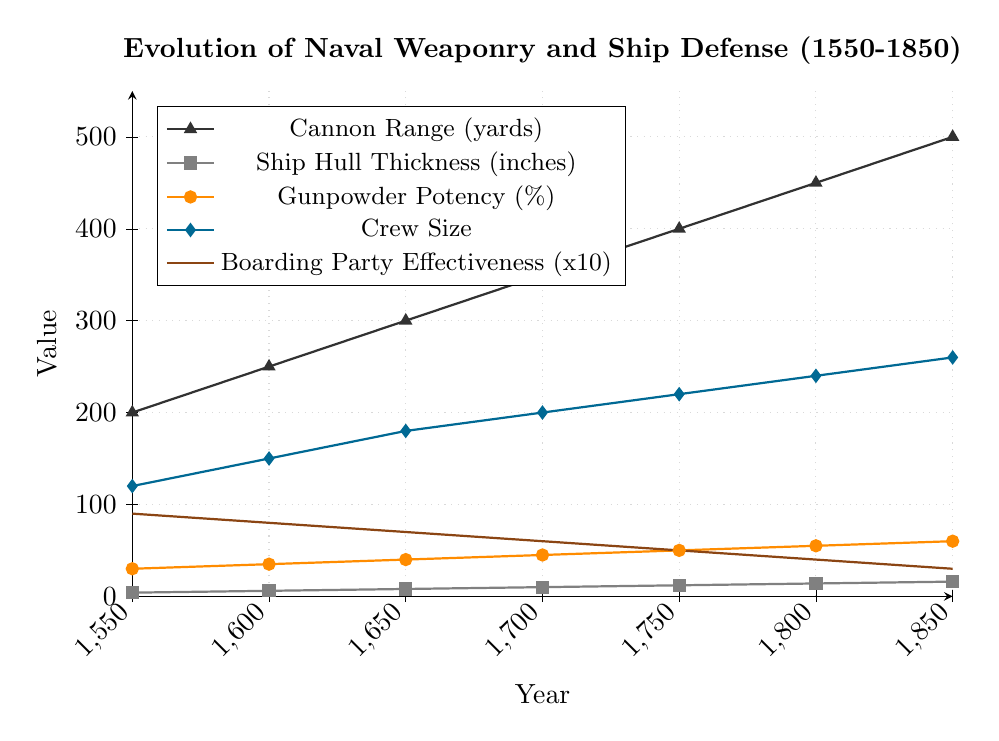What's the difference in cannon range between 1550 and 1850? Looking at the black triangles representing cannon range, in 1550, it's 200 yards, and in 1850, it's 500 yards. The difference is 500 - 200 = 300 yards.
Answer: 300 yards Between which years did the ship hull thickness increase the most? Observing the gray squares representing hull thickness, the largest increase happens between 1600 and 1650, from 6 inches to 8 inches, an increase of 2 inches. This pattern holds true for other periods with equal changes of 2 inches, but the relative increase of 2 inches from 6 to 8 inches in percentage terms is larger.
Answer: 1600 to 1650 Which metric had the highest value change throughout the entire period? Comparing all five metrics: Cannon Range (200 to 500), Ship Hull Thickness (4 to 16), Gunpowder Potency (30% to 60%), Crew Size (120 to 260), and Boarding Party Effectiveness (90*10 to 30*10). Cannon Range changes the most by 300 yards.
Answer: Cannon Range What was the ship hull thickness in 1700? Refer to the gray squares indicating hull thickness; in 1700, it's 10 inches.
Answer: 10 inches How did boarding party effectiveness change from 1550 to 1850? Looking at the brown pentagrams representing effectiveness, in 1550, it is represented as 9 (or 90), and by 1850, it's 3 (or 30). This shows a decrement from 90 to 30.
Answer: Decreased What is the visual difference between the trend lines for gunpowder potency and crew size? The orange circles (gunpowder potency) and blue diamonds (crew size) both show an increasing trend, but crew size increases more steeply and consistently compared to the more gradual increase in gunpowder potency.
Answer: Crew size increases more steeply By how many yards did the cannon range increase from 1600 to 1750? In 1600, the cannon range is 250 yards, and in 1750, it is 400 yards. The increase is 400 - 250 = 150 yards.
Answer: 150 yards Which year had the highest increase in gunpowder potency? Looking at the orange circles, the highest increase occurs between 1750 and 1800, rising from 50% to 55%, which is an increase of 5%.
Answer: 1750 to 1800 How does crew size in 1650 compare to 1750? Observing the blue diamonds, in 1650, crew size is 180, and by 1750, it is 220. Crew size increased by 40.
Answer: Increased What's the average cannon range over these years? Sum of cannon ranges = 200 + 250 + 300 + 350 + 400 + 450 + 500 = 2450 yards; number of periods = 7. Average = 2450 / 7 ≈ 350 yards.
Answer: 350 yards 